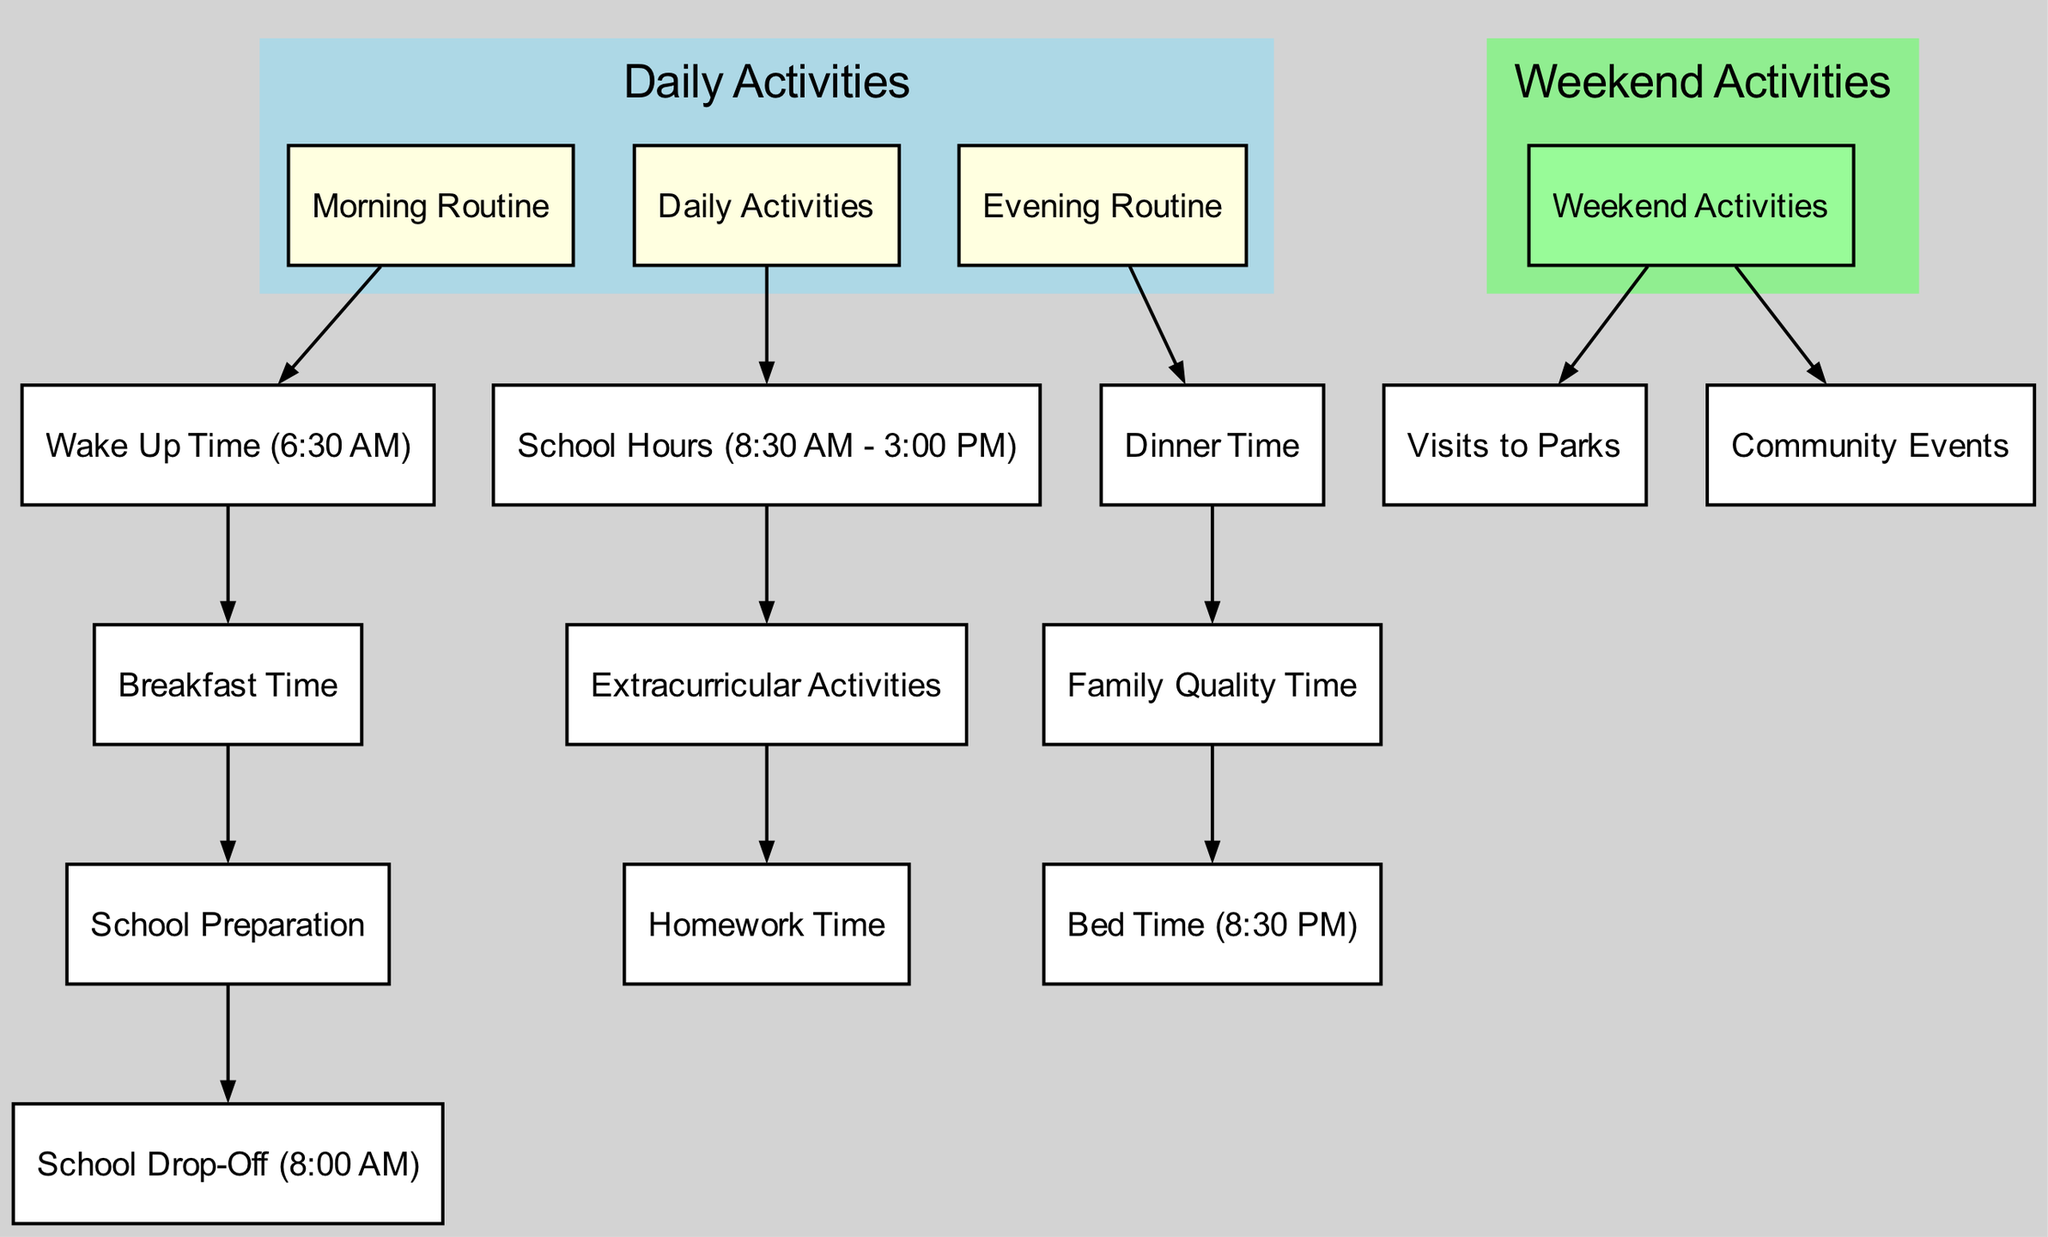what is the wake up time The diagram indicates that the 'Wake Up Time' node is connected to the 'Morning Routine' and specifies the time as '6:30 AM'.
Answer: 6:30 AM what activity follows school preparation After 'School Preparation', the next connected node is 'School Drop-Off', indicating the sequence of activities.
Answer: School Drop-Off how long are the school hours The 'School Hours' node in the diagram specifies the duration as '8:30 AM - 3:00 PM', indicating the start and end times of the school day.
Answer: 8:30 AM - 3:00 PM what comes after dinner time The diagram shows that 'Family Quality Time' follows 'Dinner Time', indicating the sequence of events in the evening routine.
Answer: Family Quality Time how many nodes are there in total By counting all the nodes listed in the data, there are a total of 15 different activities and time points depicted in the diagram.
Answer: 15 what is the final activity of the day The last node connected in the evening routine is 'Bed Time', which indicates the conclusion of daily activities.
Answer: Bed Time which activity is categorized under weekend activities The 'Weekend Activities' node has connections to 'Visits to Parks' and 'Community Events', demonstrating the types of activities planned for the weekend.
Answer: Visits to Parks, Community Events what happens after extracurricular activities The next activity after 'Extracurricular Activities' is 'Homework Time', implying the transition from one activity to the next.
Answer: Homework Time how does the evening routine start The evening routine is initiated with the 'Evening Routine' node leading to 'Dinner Time', outlining the sequence of activities in the evening.
Answer: Dinner Time 